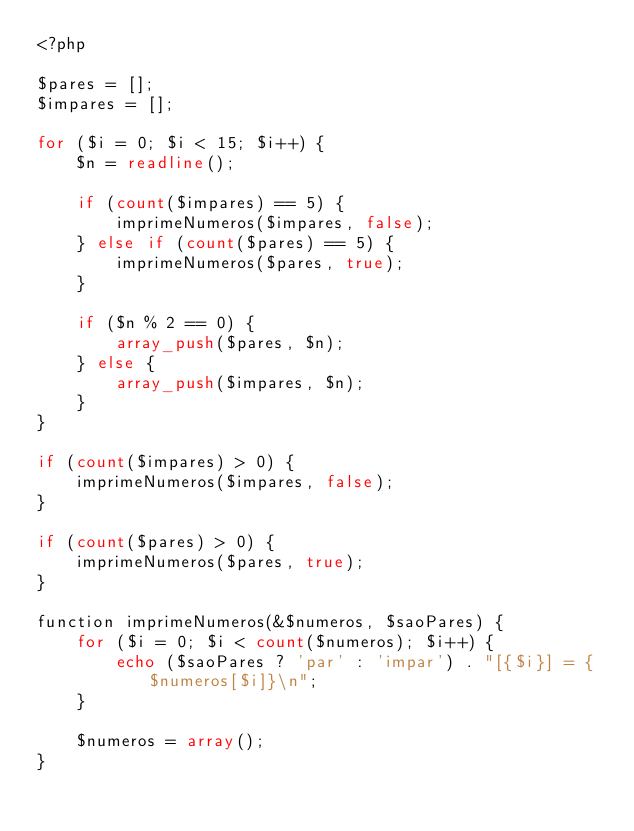Convert code to text. <code><loc_0><loc_0><loc_500><loc_500><_PHP_><?php

$pares = [];
$impares = [];

for ($i = 0; $i < 15; $i++) {
    $n = readline();

    if (count($impares) == 5) {
        imprimeNumeros($impares, false);
    } else if (count($pares) == 5) {
        imprimeNumeros($pares, true);
    }

    if ($n % 2 == 0) {
        array_push($pares, $n);
    } else {
        array_push($impares, $n);
    }
}

if (count($impares) > 0) {
    imprimeNumeros($impares, false);
}

if (count($pares) > 0) {
    imprimeNumeros($pares, true);
}

function imprimeNumeros(&$numeros, $saoPares) {
    for ($i = 0; $i < count($numeros); $i++) {
        echo ($saoPares ? 'par' : 'impar') . "[{$i}] = {$numeros[$i]}\n";
    }

    $numeros = array();
}</code> 